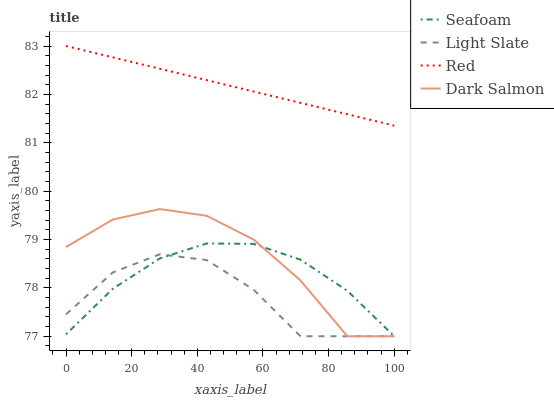Does Light Slate have the minimum area under the curve?
Answer yes or no. Yes. Does Red have the maximum area under the curve?
Answer yes or no. Yes. Does Seafoam have the minimum area under the curve?
Answer yes or no. No. Does Seafoam have the maximum area under the curve?
Answer yes or no. No. Is Red the smoothest?
Answer yes or no. Yes. Is Dark Salmon the roughest?
Answer yes or no. Yes. Is Seafoam the smoothest?
Answer yes or no. No. Is Seafoam the roughest?
Answer yes or no. No. Does Light Slate have the lowest value?
Answer yes or no. Yes. Does Red have the lowest value?
Answer yes or no. No. Does Red have the highest value?
Answer yes or no. Yes. Does Seafoam have the highest value?
Answer yes or no. No. Is Light Slate less than Red?
Answer yes or no. Yes. Is Red greater than Dark Salmon?
Answer yes or no. Yes. Does Light Slate intersect Seafoam?
Answer yes or no. Yes. Is Light Slate less than Seafoam?
Answer yes or no. No. Is Light Slate greater than Seafoam?
Answer yes or no. No. Does Light Slate intersect Red?
Answer yes or no. No. 